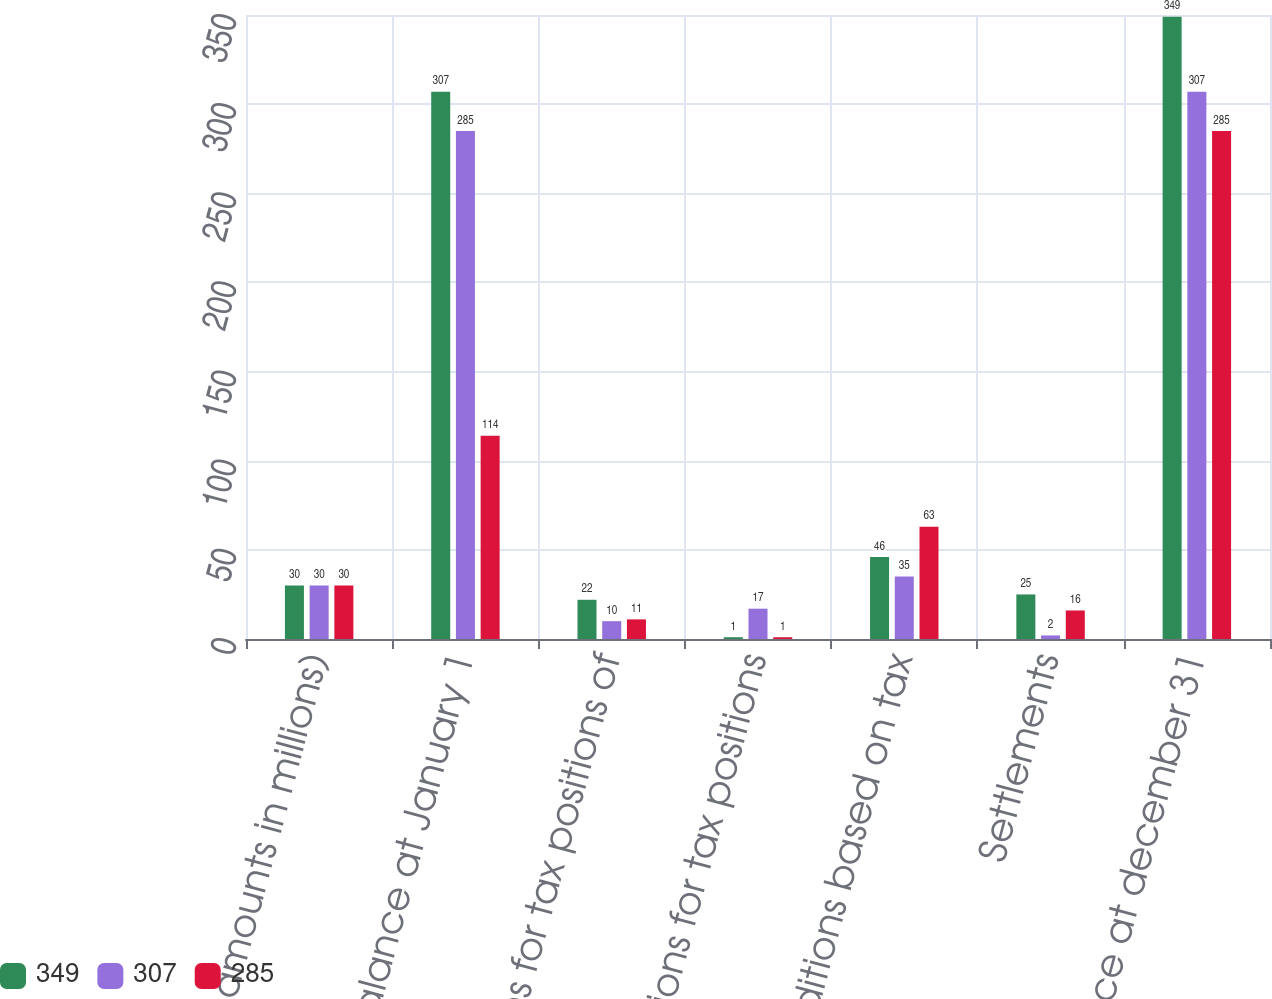Convert chart to OTSL. <chart><loc_0><loc_0><loc_500><loc_500><stacked_bar_chart><ecel><fcel>(Dollar amounts in millions)<fcel>Balance at January 1<fcel>additions for tax positions of<fcel>Reductions for tax positions<fcel>additions based on tax<fcel>Settlements<fcel>Balance at december 31<nl><fcel>349<fcel>30<fcel>307<fcel>22<fcel>1<fcel>46<fcel>25<fcel>349<nl><fcel>307<fcel>30<fcel>285<fcel>10<fcel>17<fcel>35<fcel>2<fcel>307<nl><fcel>285<fcel>30<fcel>114<fcel>11<fcel>1<fcel>63<fcel>16<fcel>285<nl></chart> 